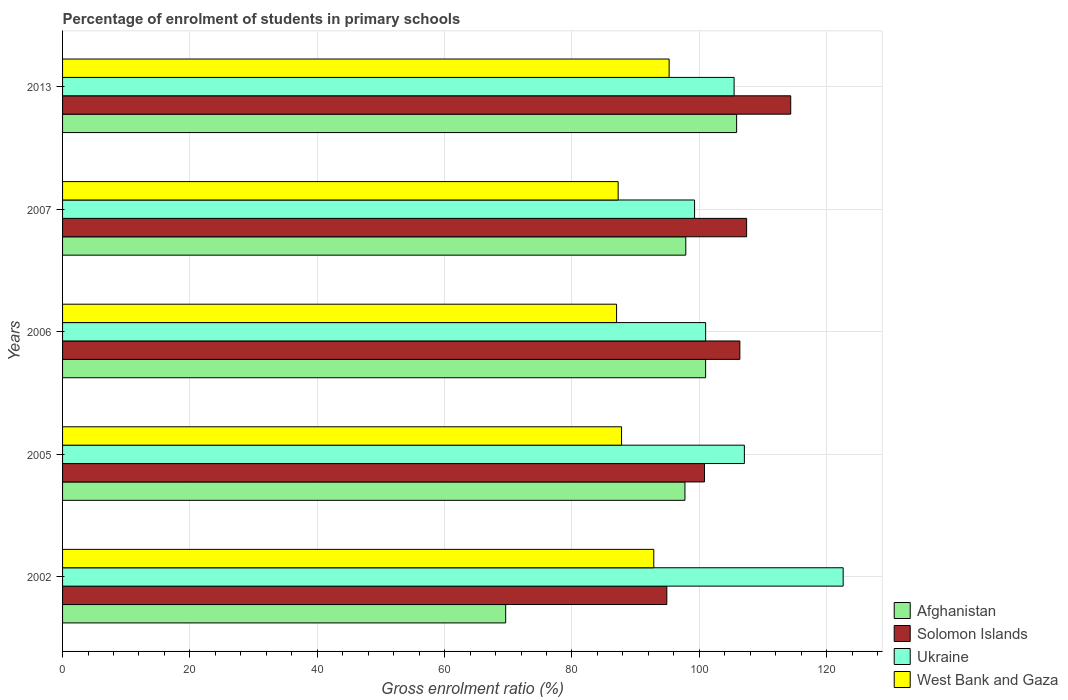How many bars are there on the 4th tick from the bottom?
Make the answer very short. 4. In how many cases, is the number of bars for a given year not equal to the number of legend labels?
Provide a succinct answer. 0. What is the percentage of students enrolled in primary schools in West Bank and Gaza in 2005?
Give a very brief answer. 87.79. Across all years, what is the maximum percentage of students enrolled in primary schools in Solomon Islands?
Make the answer very short. 114.36. Across all years, what is the minimum percentage of students enrolled in primary schools in Solomon Islands?
Offer a terse response. 94.9. In which year was the percentage of students enrolled in primary schools in Ukraine maximum?
Keep it short and to the point. 2002. In which year was the percentage of students enrolled in primary schools in West Bank and Gaza minimum?
Offer a terse response. 2006. What is the total percentage of students enrolled in primary schools in Ukraine in the graph?
Your answer should be very brief. 535.39. What is the difference between the percentage of students enrolled in primary schools in West Bank and Gaza in 2002 and that in 2005?
Offer a terse response. 5.06. What is the difference between the percentage of students enrolled in primary schools in Ukraine in 2006 and the percentage of students enrolled in primary schools in West Bank and Gaza in 2002?
Your answer should be very brief. 8.14. What is the average percentage of students enrolled in primary schools in West Bank and Gaza per year?
Offer a terse response. 90.03. In the year 2005, what is the difference between the percentage of students enrolled in primary schools in Ukraine and percentage of students enrolled in primary schools in Solomon Islands?
Ensure brevity in your answer.  6.27. In how many years, is the percentage of students enrolled in primary schools in Afghanistan greater than 64 %?
Offer a very short reply. 5. What is the ratio of the percentage of students enrolled in primary schools in Ukraine in 2002 to that in 2005?
Your answer should be compact. 1.14. Is the difference between the percentage of students enrolled in primary schools in Ukraine in 2002 and 2006 greater than the difference between the percentage of students enrolled in primary schools in Solomon Islands in 2002 and 2006?
Keep it short and to the point. Yes. What is the difference between the highest and the second highest percentage of students enrolled in primary schools in West Bank and Gaza?
Give a very brief answer. 2.41. What is the difference between the highest and the lowest percentage of students enrolled in primary schools in Solomon Islands?
Give a very brief answer. 19.46. Is it the case that in every year, the sum of the percentage of students enrolled in primary schools in Afghanistan and percentage of students enrolled in primary schools in West Bank and Gaza is greater than the sum of percentage of students enrolled in primary schools in Ukraine and percentage of students enrolled in primary schools in Solomon Islands?
Provide a succinct answer. No. What does the 4th bar from the top in 2007 represents?
Your response must be concise. Afghanistan. What does the 1st bar from the bottom in 2007 represents?
Provide a short and direct response. Afghanistan. Is it the case that in every year, the sum of the percentage of students enrolled in primary schools in Solomon Islands and percentage of students enrolled in primary schools in West Bank and Gaza is greater than the percentage of students enrolled in primary schools in Afghanistan?
Keep it short and to the point. Yes. Are all the bars in the graph horizontal?
Offer a very short reply. Yes. What is the difference between two consecutive major ticks on the X-axis?
Provide a short and direct response. 20. Are the values on the major ticks of X-axis written in scientific E-notation?
Give a very brief answer. No. How are the legend labels stacked?
Give a very brief answer. Vertical. What is the title of the graph?
Keep it short and to the point. Percentage of enrolment of students in primary schools. What is the label or title of the X-axis?
Provide a succinct answer. Gross enrolment ratio (%). What is the Gross enrolment ratio (%) in Afghanistan in 2002?
Your answer should be compact. 69.59. What is the Gross enrolment ratio (%) of Solomon Islands in 2002?
Provide a short and direct response. 94.9. What is the Gross enrolment ratio (%) of Ukraine in 2002?
Ensure brevity in your answer.  122.59. What is the Gross enrolment ratio (%) in West Bank and Gaza in 2002?
Your response must be concise. 92.85. What is the Gross enrolment ratio (%) in Afghanistan in 2005?
Provide a succinct answer. 97.74. What is the Gross enrolment ratio (%) in Solomon Islands in 2005?
Your answer should be very brief. 100.81. What is the Gross enrolment ratio (%) in Ukraine in 2005?
Your response must be concise. 107.08. What is the Gross enrolment ratio (%) in West Bank and Gaza in 2005?
Keep it short and to the point. 87.79. What is the Gross enrolment ratio (%) of Afghanistan in 2006?
Offer a very short reply. 100.99. What is the Gross enrolment ratio (%) of Solomon Islands in 2006?
Ensure brevity in your answer.  106.37. What is the Gross enrolment ratio (%) of Ukraine in 2006?
Your answer should be very brief. 100.99. What is the Gross enrolment ratio (%) in West Bank and Gaza in 2006?
Offer a very short reply. 87.01. What is the Gross enrolment ratio (%) in Afghanistan in 2007?
Give a very brief answer. 97.88. What is the Gross enrolment ratio (%) in Solomon Islands in 2007?
Your answer should be very brief. 107.43. What is the Gross enrolment ratio (%) of Ukraine in 2007?
Offer a very short reply. 99.26. What is the Gross enrolment ratio (%) of West Bank and Gaza in 2007?
Make the answer very short. 87.26. What is the Gross enrolment ratio (%) of Afghanistan in 2013?
Make the answer very short. 105.86. What is the Gross enrolment ratio (%) in Solomon Islands in 2013?
Your response must be concise. 114.36. What is the Gross enrolment ratio (%) in Ukraine in 2013?
Your answer should be very brief. 105.47. What is the Gross enrolment ratio (%) in West Bank and Gaza in 2013?
Provide a short and direct response. 95.26. Across all years, what is the maximum Gross enrolment ratio (%) of Afghanistan?
Give a very brief answer. 105.86. Across all years, what is the maximum Gross enrolment ratio (%) in Solomon Islands?
Your answer should be very brief. 114.36. Across all years, what is the maximum Gross enrolment ratio (%) in Ukraine?
Keep it short and to the point. 122.59. Across all years, what is the maximum Gross enrolment ratio (%) in West Bank and Gaza?
Your response must be concise. 95.26. Across all years, what is the minimum Gross enrolment ratio (%) of Afghanistan?
Keep it short and to the point. 69.59. Across all years, what is the minimum Gross enrolment ratio (%) of Solomon Islands?
Provide a succinct answer. 94.9. Across all years, what is the minimum Gross enrolment ratio (%) in Ukraine?
Ensure brevity in your answer.  99.26. Across all years, what is the minimum Gross enrolment ratio (%) of West Bank and Gaza?
Your answer should be very brief. 87.01. What is the total Gross enrolment ratio (%) in Afghanistan in the graph?
Give a very brief answer. 472.06. What is the total Gross enrolment ratio (%) of Solomon Islands in the graph?
Your response must be concise. 523.87. What is the total Gross enrolment ratio (%) of Ukraine in the graph?
Offer a very short reply. 535.39. What is the total Gross enrolment ratio (%) in West Bank and Gaza in the graph?
Provide a succinct answer. 450.16. What is the difference between the Gross enrolment ratio (%) of Afghanistan in 2002 and that in 2005?
Your answer should be compact. -28.15. What is the difference between the Gross enrolment ratio (%) in Solomon Islands in 2002 and that in 2005?
Offer a terse response. -5.91. What is the difference between the Gross enrolment ratio (%) in Ukraine in 2002 and that in 2005?
Your answer should be very brief. 15.51. What is the difference between the Gross enrolment ratio (%) in West Bank and Gaza in 2002 and that in 2005?
Give a very brief answer. 5.06. What is the difference between the Gross enrolment ratio (%) of Afghanistan in 2002 and that in 2006?
Ensure brevity in your answer.  -31.4. What is the difference between the Gross enrolment ratio (%) of Solomon Islands in 2002 and that in 2006?
Offer a very short reply. -11.47. What is the difference between the Gross enrolment ratio (%) of Ukraine in 2002 and that in 2006?
Your answer should be compact. 21.6. What is the difference between the Gross enrolment ratio (%) in West Bank and Gaza in 2002 and that in 2006?
Keep it short and to the point. 5.84. What is the difference between the Gross enrolment ratio (%) in Afghanistan in 2002 and that in 2007?
Offer a very short reply. -28.29. What is the difference between the Gross enrolment ratio (%) in Solomon Islands in 2002 and that in 2007?
Your response must be concise. -12.53. What is the difference between the Gross enrolment ratio (%) in Ukraine in 2002 and that in 2007?
Offer a very short reply. 23.34. What is the difference between the Gross enrolment ratio (%) in West Bank and Gaza in 2002 and that in 2007?
Ensure brevity in your answer.  5.59. What is the difference between the Gross enrolment ratio (%) in Afghanistan in 2002 and that in 2013?
Provide a short and direct response. -36.27. What is the difference between the Gross enrolment ratio (%) of Solomon Islands in 2002 and that in 2013?
Your answer should be compact. -19.46. What is the difference between the Gross enrolment ratio (%) in Ukraine in 2002 and that in 2013?
Make the answer very short. 17.13. What is the difference between the Gross enrolment ratio (%) in West Bank and Gaza in 2002 and that in 2013?
Your answer should be compact. -2.41. What is the difference between the Gross enrolment ratio (%) in Afghanistan in 2005 and that in 2006?
Your response must be concise. -3.24. What is the difference between the Gross enrolment ratio (%) of Solomon Islands in 2005 and that in 2006?
Keep it short and to the point. -5.56. What is the difference between the Gross enrolment ratio (%) of Ukraine in 2005 and that in 2006?
Your answer should be very brief. 6.08. What is the difference between the Gross enrolment ratio (%) of West Bank and Gaza in 2005 and that in 2006?
Your answer should be compact. 0.78. What is the difference between the Gross enrolment ratio (%) of Afghanistan in 2005 and that in 2007?
Ensure brevity in your answer.  -0.13. What is the difference between the Gross enrolment ratio (%) of Solomon Islands in 2005 and that in 2007?
Provide a succinct answer. -6.62. What is the difference between the Gross enrolment ratio (%) in Ukraine in 2005 and that in 2007?
Your answer should be very brief. 7.82. What is the difference between the Gross enrolment ratio (%) in West Bank and Gaza in 2005 and that in 2007?
Offer a terse response. 0.53. What is the difference between the Gross enrolment ratio (%) in Afghanistan in 2005 and that in 2013?
Make the answer very short. -8.12. What is the difference between the Gross enrolment ratio (%) of Solomon Islands in 2005 and that in 2013?
Give a very brief answer. -13.54. What is the difference between the Gross enrolment ratio (%) in Ukraine in 2005 and that in 2013?
Your answer should be compact. 1.61. What is the difference between the Gross enrolment ratio (%) of West Bank and Gaza in 2005 and that in 2013?
Provide a short and direct response. -7.47. What is the difference between the Gross enrolment ratio (%) of Afghanistan in 2006 and that in 2007?
Ensure brevity in your answer.  3.11. What is the difference between the Gross enrolment ratio (%) in Solomon Islands in 2006 and that in 2007?
Make the answer very short. -1.06. What is the difference between the Gross enrolment ratio (%) in Ukraine in 2006 and that in 2007?
Offer a terse response. 1.74. What is the difference between the Gross enrolment ratio (%) in West Bank and Gaza in 2006 and that in 2007?
Offer a very short reply. -0.25. What is the difference between the Gross enrolment ratio (%) in Afghanistan in 2006 and that in 2013?
Make the answer very short. -4.87. What is the difference between the Gross enrolment ratio (%) of Solomon Islands in 2006 and that in 2013?
Offer a terse response. -7.99. What is the difference between the Gross enrolment ratio (%) of Ukraine in 2006 and that in 2013?
Your answer should be very brief. -4.47. What is the difference between the Gross enrolment ratio (%) of West Bank and Gaza in 2006 and that in 2013?
Make the answer very short. -8.25. What is the difference between the Gross enrolment ratio (%) of Afghanistan in 2007 and that in 2013?
Keep it short and to the point. -7.98. What is the difference between the Gross enrolment ratio (%) of Solomon Islands in 2007 and that in 2013?
Keep it short and to the point. -6.92. What is the difference between the Gross enrolment ratio (%) in Ukraine in 2007 and that in 2013?
Provide a short and direct response. -6.21. What is the difference between the Gross enrolment ratio (%) in West Bank and Gaza in 2007 and that in 2013?
Provide a succinct answer. -8. What is the difference between the Gross enrolment ratio (%) in Afghanistan in 2002 and the Gross enrolment ratio (%) in Solomon Islands in 2005?
Give a very brief answer. -31.22. What is the difference between the Gross enrolment ratio (%) of Afghanistan in 2002 and the Gross enrolment ratio (%) of Ukraine in 2005?
Offer a very short reply. -37.49. What is the difference between the Gross enrolment ratio (%) in Afghanistan in 2002 and the Gross enrolment ratio (%) in West Bank and Gaza in 2005?
Ensure brevity in your answer.  -18.2. What is the difference between the Gross enrolment ratio (%) of Solomon Islands in 2002 and the Gross enrolment ratio (%) of Ukraine in 2005?
Your response must be concise. -12.18. What is the difference between the Gross enrolment ratio (%) of Solomon Islands in 2002 and the Gross enrolment ratio (%) of West Bank and Gaza in 2005?
Make the answer very short. 7.11. What is the difference between the Gross enrolment ratio (%) of Ukraine in 2002 and the Gross enrolment ratio (%) of West Bank and Gaza in 2005?
Ensure brevity in your answer.  34.8. What is the difference between the Gross enrolment ratio (%) of Afghanistan in 2002 and the Gross enrolment ratio (%) of Solomon Islands in 2006?
Your response must be concise. -36.78. What is the difference between the Gross enrolment ratio (%) of Afghanistan in 2002 and the Gross enrolment ratio (%) of Ukraine in 2006?
Offer a very short reply. -31.4. What is the difference between the Gross enrolment ratio (%) of Afghanistan in 2002 and the Gross enrolment ratio (%) of West Bank and Gaza in 2006?
Your answer should be compact. -17.41. What is the difference between the Gross enrolment ratio (%) of Solomon Islands in 2002 and the Gross enrolment ratio (%) of Ukraine in 2006?
Your answer should be compact. -6.09. What is the difference between the Gross enrolment ratio (%) of Solomon Islands in 2002 and the Gross enrolment ratio (%) of West Bank and Gaza in 2006?
Offer a terse response. 7.89. What is the difference between the Gross enrolment ratio (%) of Ukraine in 2002 and the Gross enrolment ratio (%) of West Bank and Gaza in 2006?
Your answer should be very brief. 35.59. What is the difference between the Gross enrolment ratio (%) of Afghanistan in 2002 and the Gross enrolment ratio (%) of Solomon Islands in 2007?
Keep it short and to the point. -37.84. What is the difference between the Gross enrolment ratio (%) in Afghanistan in 2002 and the Gross enrolment ratio (%) in Ukraine in 2007?
Give a very brief answer. -29.66. What is the difference between the Gross enrolment ratio (%) of Afghanistan in 2002 and the Gross enrolment ratio (%) of West Bank and Gaza in 2007?
Your answer should be compact. -17.66. What is the difference between the Gross enrolment ratio (%) of Solomon Islands in 2002 and the Gross enrolment ratio (%) of Ukraine in 2007?
Provide a short and direct response. -4.36. What is the difference between the Gross enrolment ratio (%) in Solomon Islands in 2002 and the Gross enrolment ratio (%) in West Bank and Gaza in 2007?
Keep it short and to the point. 7.64. What is the difference between the Gross enrolment ratio (%) of Ukraine in 2002 and the Gross enrolment ratio (%) of West Bank and Gaza in 2007?
Keep it short and to the point. 35.34. What is the difference between the Gross enrolment ratio (%) in Afghanistan in 2002 and the Gross enrolment ratio (%) in Solomon Islands in 2013?
Ensure brevity in your answer.  -44.76. What is the difference between the Gross enrolment ratio (%) in Afghanistan in 2002 and the Gross enrolment ratio (%) in Ukraine in 2013?
Keep it short and to the point. -35.87. What is the difference between the Gross enrolment ratio (%) of Afghanistan in 2002 and the Gross enrolment ratio (%) of West Bank and Gaza in 2013?
Give a very brief answer. -25.67. What is the difference between the Gross enrolment ratio (%) in Solomon Islands in 2002 and the Gross enrolment ratio (%) in Ukraine in 2013?
Your answer should be compact. -10.57. What is the difference between the Gross enrolment ratio (%) in Solomon Islands in 2002 and the Gross enrolment ratio (%) in West Bank and Gaza in 2013?
Your answer should be very brief. -0.36. What is the difference between the Gross enrolment ratio (%) of Ukraine in 2002 and the Gross enrolment ratio (%) of West Bank and Gaza in 2013?
Ensure brevity in your answer.  27.33. What is the difference between the Gross enrolment ratio (%) in Afghanistan in 2005 and the Gross enrolment ratio (%) in Solomon Islands in 2006?
Your answer should be very brief. -8.62. What is the difference between the Gross enrolment ratio (%) in Afghanistan in 2005 and the Gross enrolment ratio (%) in Ukraine in 2006?
Offer a very short reply. -3.25. What is the difference between the Gross enrolment ratio (%) of Afghanistan in 2005 and the Gross enrolment ratio (%) of West Bank and Gaza in 2006?
Your answer should be very brief. 10.74. What is the difference between the Gross enrolment ratio (%) of Solomon Islands in 2005 and the Gross enrolment ratio (%) of Ukraine in 2006?
Offer a very short reply. -0.18. What is the difference between the Gross enrolment ratio (%) in Solomon Islands in 2005 and the Gross enrolment ratio (%) in West Bank and Gaza in 2006?
Your response must be concise. 13.81. What is the difference between the Gross enrolment ratio (%) of Ukraine in 2005 and the Gross enrolment ratio (%) of West Bank and Gaza in 2006?
Ensure brevity in your answer.  20.07. What is the difference between the Gross enrolment ratio (%) of Afghanistan in 2005 and the Gross enrolment ratio (%) of Solomon Islands in 2007?
Provide a succinct answer. -9.69. What is the difference between the Gross enrolment ratio (%) in Afghanistan in 2005 and the Gross enrolment ratio (%) in Ukraine in 2007?
Provide a short and direct response. -1.51. What is the difference between the Gross enrolment ratio (%) of Afghanistan in 2005 and the Gross enrolment ratio (%) of West Bank and Gaza in 2007?
Offer a very short reply. 10.49. What is the difference between the Gross enrolment ratio (%) in Solomon Islands in 2005 and the Gross enrolment ratio (%) in Ukraine in 2007?
Provide a succinct answer. 1.56. What is the difference between the Gross enrolment ratio (%) in Solomon Islands in 2005 and the Gross enrolment ratio (%) in West Bank and Gaza in 2007?
Provide a succinct answer. 13.56. What is the difference between the Gross enrolment ratio (%) in Ukraine in 2005 and the Gross enrolment ratio (%) in West Bank and Gaza in 2007?
Your answer should be compact. 19.82. What is the difference between the Gross enrolment ratio (%) in Afghanistan in 2005 and the Gross enrolment ratio (%) in Solomon Islands in 2013?
Keep it short and to the point. -16.61. What is the difference between the Gross enrolment ratio (%) in Afghanistan in 2005 and the Gross enrolment ratio (%) in Ukraine in 2013?
Provide a short and direct response. -7.72. What is the difference between the Gross enrolment ratio (%) of Afghanistan in 2005 and the Gross enrolment ratio (%) of West Bank and Gaza in 2013?
Offer a very short reply. 2.49. What is the difference between the Gross enrolment ratio (%) in Solomon Islands in 2005 and the Gross enrolment ratio (%) in Ukraine in 2013?
Your answer should be compact. -4.65. What is the difference between the Gross enrolment ratio (%) of Solomon Islands in 2005 and the Gross enrolment ratio (%) of West Bank and Gaza in 2013?
Your answer should be compact. 5.55. What is the difference between the Gross enrolment ratio (%) in Ukraine in 2005 and the Gross enrolment ratio (%) in West Bank and Gaza in 2013?
Your answer should be compact. 11.82. What is the difference between the Gross enrolment ratio (%) in Afghanistan in 2006 and the Gross enrolment ratio (%) in Solomon Islands in 2007?
Give a very brief answer. -6.44. What is the difference between the Gross enrolment ratio (%) in Afghanistan in 2006 and the Gross enrolment ratio (%) in Ukraine in 2007?
Your response must be concise. 1.73. What is the difference between the Gross enrolment ratio (%) in Afghanistan in 2006 and the Gross enrolment ratio (%) in West Bank and Gaza in 2007?
Your answer should be compact. 13.73. What is the difference between the Gross enrolment ratio (%) in Solomon Islands in 2006 and the Gross enrolment ratio (%) in Ukraine in 2007?
Give a very brief answer. 7.11. What is the difference between the Gross enrolment ratio (%) of Solomon Islands in 2006 and the Gross enrolment ratio (%) of West Bank and Gaza in 2007?
Your response must be concise. 19.11. What is the difference between the Gross enrolment ratio (%) in Ukraine in 2006 and the Gross enrolment ratio (%) in West Bank and Gaza in 2007?
Keep it short and to the point. 13.74. What is the difference between the Gross enrolment ratio (%) in Afghanistan in 2006 and the Gross enrolment ratio (%) in Solomon Islands in 2013?
Provide a short and direct response. -13.37. What is the difference between the Gross enrolment ratio (%) in Afghanistan in 2006 and the Gross enrolment ratio (%) in Ukraine in 2013?
Provide a succinct answer. -4.48. What is the difference between the Gross enrolment ratio (%) of Afghanistan in 2006 and the Gross enrolment ratio (%) of West Bank and Gaza in 2013?
Offer a very short reply. 5.73. What is the difference between the Gross enrolment ratio (%) of Solomon Islands in 2006 and the Gross enrolment ratio (%) of Ukraine in 2013?
Your response must be concise. 0.9. What is the difference between the Gross enrolment ratio (%) of Solomon Islands in 2006 and the Gross enrolment ratio (%) of West Bank and Gaza in 2013?
Provide a short and direct response. 11.11. What is the difference between the Gross enrolment ratio (%) in Ukraine in 2006 and the Gross enrolment ratio (%) in West Bank and Gaza in 2013?
Keep it short and to the point. 5.74. What is the difference between the Gross enrolment ratio (%) in Afghanistan in 2007 and the Gross enrolment ratio (%) in Solomon Islands in 2013?
Offer a terse response. -16.48. What is the difference between the Gross enrolment ratio (%) of Afghanistan in 2007 and the Gross enrolment ratio (%) of Ukraine in 2013?
Keep it short and to the point. -7.59. What is the difference between the Gross enrolment ratio (%) in Afghanistan in 2007 and the Gross enrolment ratio (%) in West Bank and Gaza in 2013?
Provide a succinct answer. 2.62. What is the difference between the Gross enrolment ratio (%) of Solomon Islands in 2007 and the Gross enrolment ratio (%) of Ukraine in 2013?
Offer a terse response. 1.97. What is the difference between the Gross enrolment ratio (%) of Solomon Islands in 2007 and the Gross enrolment ratio (%) of West Bank and Gaza in 2013?
Give a very brief answer. 12.17. What is the difference between the Gross enrolment ratio (%) in Ukraine in 2007 and the Gross enrolment ratio (%) in West Bank and Gaza in 2013?
Give a very brief answer. 4. What is the average Gross enrolment ratio (%) of Afghanistan per year?
Your answer should be compact. 94.41. What is the average Gross enrolment ratio (%) in Solomon Islands per year?
Ensure brevity in your answer.  104.77. What is the average Gross enrolment ratio (%) in Ukraine per year?
Your answer should be very brief. 107.08. What is the average Gross enrolment ratio (%) in West Bank and Gaza per year?
Ensure brevity in your answer.  90.03. In the year 2002, what is the difference between the Gross enrolment ratio (%) in Afghanistan and Gross enrolment ratio (%) in Solomon Islands?
Offer a terse response. -25.31. In the year 2002, what is the difference between the Gross enrolment ratio (%) in Afghanistan and Gross enrolment ratio (%) in Ukraine?
Your answer should be very brief. -53. In the year 2002, what is the difference between the Gross enrolment ratio (%) of Afghanistan and Gross enrolment ratio (%) of West Bank and Gaza?
Offer a terse response. -23.26. In the year 2002, what is the difference between the Gross enrolment ratio (%) in Solomon Islands and Gross enrolment ratio (%) in Ukraine?
Your response must be concise. -27.69. In the year 2002, what is the difference between the Gross enrolment ratio (%) in Solomon Islands and Gross enrolment ratio (%) in West Bank and Gaza?
Offer a terse response. 2.05. In the year 2002, what is the difference between the Gross enrolment ratio (%) in Ukraine and Gross enrolment ratio (%) in West Bank and Gaza?
Make the answer very short. 29.74. In the year 2005, what is the difference between the Gross enrolment ratio (%) in Afghanistan and Gross enrolment ratio (%) in Solomon Islands?
Provide a short and direct response. -3.07. In the year 2005, what is the difference between the Gross enrolment ratio (%) in Afghanistan and Gross enrolment ratio (%) in Ukraine?
Provide a succinct answer. -9.33. In the year 2005, what is the difference between the Gross enrolment ratio (%) of Afghanistan and Gross enrolment ratio (%) of West Bank and Gaza?
Your answer should be compact. 9.95. In the year 2005, what is the difference between the Gross enrolment ratio (%) in Solomon Islands and Gross enrolment ratio (%) in Ukraine?
Keep it short and to the point. -6.27. In the year 2005, what is the difference between the Gross enrolment ratio (%) in Solomon Islands and Gross enrolment ratio (%) in West Bank and Gaza?
Offer a very short reply. 13.02. In the year 2005, what is the difference between the Gross enrolment ratio (%) in Ukraine and Gross enrolment ratio (%) in West Bank and Gaza?
Ensure brevity in your answer.  19.29. In the year 2006, what is the difference between the Gross enrolment ratio (%) of Afghanistan and Gross enrolment ratio (%) of Solomon Islands?
Provide a succinct answer. -5.38. In the year 2006, what is the difference between the Gross enrolment ratio (%) of Afghanistan and Gross enrolment ratio (%) of Ukraine?
Give a very brief answer. -0.01. In the year 2006, what is the difference between the Gross enrolment ratio (%) of Afghanistan and Gross enrolment ratio (%) of West Bank and Gaza?
Offer a terse response. 13.98. In the year 2006, what is the difference between the Gross enrolment ratio (%) in Solomon Islands and Gross enrolment ratio (%) in Ukraine?
Ensure brevity in your answer.  5.37. In the year 2006, what is the difference between the Gross enrolment ratio (%) in Solomon Islands and Gross enrolment ratio (%) in West Bank and Gaza?
Offer a terse response. 19.36. In the year 2006, what is the difference between the Gross enrolment ratio (%) of Ukraine and Gross enrolment ratio (%) of West Bank and Gaza?
Your answer should be compact. 13.99. In the year 2007, what is the difference between the Gross enrolment ratio (%) in Afghanistan and Gross enrolment ratio (%) in Solomon Islands?
Provide a short and direct response. -9.55. In the year 2007, what is the difference between the Gross enrolment ratio (%) in Afghanistan and Gross enrolment ratio (%) in Ukraine?
Keep it short and to the point. -1.38. In the year 2007, what is the difference between the Gross enrolment ratio (%) of Afghanistan and Gross enrolment ratio (%) of West Bank and Gaza?
Ensure brevity in your answer.  10.62. In the year 2007, what is the difference between the Gross enrolment ratio (%) in Solomon Islands and Gross enrolment ratio (%) in Ukraine?
Your answer should be very brief. 8.18. In the year 2007, what is the difference between the Gross enrolment ratio (%) of Solomon Islands and Gross enrolment ratio (%) of West Bank and Gaza?
Give a very brief answer. 20.17. In the year 2007, what is the difference between the Gross enrolment ratio (%) in Ukraine and Gross enrolment ratio (%) in West Bank and Gaza?
Keep it short and to the point. 12. In the year 2013, what is the difference between the Gross enrolment ratio (%) of Afghanistan and Gross enrolment ratio (%) of Solomon Islands?
Your answer should be very brief. -8.5. In the year 2013, what is the difference between the Gross enrolment ratio (%) in Afghanistan and Gross enrolment ratio (%) in Ukraine?
Ensure brevity in your answer.  0.39. In the year 2013, what is the difference between the Gross enrolment ratio (%) in Afghanistan and Gross enrolment ratio (%) in West Bank and Gaza?
Your response must be concise. 10.6. In the year 2013, what is the difference between the Gross enrolment ratio (%) of Solomon Islands and Gross enrolment ratio (%) of Ukraine?
Your response must be concise. 8.89. In the year 2013, what is the difference between the Gross enrolment ratio (%) in Solomon Islands and Gross enrolment ratio (%) in West Bank and Gaza?
Make the answer very short. 19.1. In the year 2013, what is the difference between the Gross enrolment ratio (%) of Ukraine and Gross enrolment ratio (%) of West Bank and Gaza?
Provide a succinct answer. 10.21. What is the ratio of the Gross enrolment ratio (%) in Afghanistan in 2002 to that in 2005?
Provide a succinct answer. 0.71. What is the ratio of the Gross enrolment ratio (%) in Solomon Islands in 2002 to that in 2005?
Offer a terse response. 0.94. What is the ratio of the Gross enrolment ratio (%) of Ukraine in 2002 to that in 2005?
Provide a succinct answer. 1.14. What is the ratio of the Gross enrolment ratio (%) in West Bank and Gaza in 2002 to that in 2005?
Ensure brevity in your answer.  1.06. What is the ratio of the Gross enrolment ratio (%) in Afghanistan in 2002 to that in 2006?
Ensure brevity in your answer.  0.69. What is the ratio of the Gross enrolment ratio (%) of Solomon Islands in 2002 to that in 2006?
Ensure brevity in your answer.  0.89. What is the ratio of the Gross enrolment ratio (%) in Ukraine in 2002 to that in 2006?
Provide a succinct answer. 1.21. What is the ratio of the Gross enrolment ratio (%) in West Bank and Gaza in 2002 to that in 2006?
Your answer should be very brief. 1.07. What is the ratio of the Gross enrolment ratio (%) of Afghanistan in 2002 to that in 2007?
Offer a terse response. 0.71. What is the ratio of the Gross enrolment ratio (%) of Solomon Islands in 2002 to that in 2007?
Ensure brevity in your answer.  0.88. What is the ratio of the Gross enrolment ratio (%) in Ukraine in 2002 to that in 2007?
Ensure brevity in your answer.  1.24. What is the ratio of the Gross enrolment ratio (%) of West Bank and Gaza in 2002 to that in 2007?
Offer a terse response. 1.06. What is the ratio of the Gross enrolment ratio (%) of Afghanistan in 2002 to that in 2013?
Give a very brief answer. 0.66. What is the ratio of the Gross enrolment ratio (%) in Solomon Islands in 2002 to that in 2013?
Your answer should be very brief. 0.83. What is the ratio of the Gross enrolment ratio (%) in Ukraine in 2002 to that in 2013?
Give a very brief answer. 1.16. What is the ratio of the Gross enrolment ratio (%) in West Bank and Gaza in 2002 to that in 2013?
Offer a very short reply. 0.97. What is the ratio of the Gross enrolment ratio (%) of Afghanistan in 2005 to that in 2006?
Your response must be concise. 0.97. What is the ratio of the Gross enrolment ratio (%) in Solomon Islands in 2005 to that in 2006?
Offer a terse response. 0.95. What is the ratio of the Gross enrolment ratio (%) in Ukraine in 2005 to that in 2006?
Give a very brief answer. 1.06. What is the ratio of the Gross enrolment ratio (%) of Solomon Islands in 2005 to that in 2007?
Your answer should be very brief. 0.94. What is the ratio of the Gross enrolment ratio (%) in Ukraine in 2005 to that in 2007?
Ensure brevity in your answer.  1.08. What is the ratio of the Gross enrolment ratio (%) of Afghanistan in 2005 to that in 2013?
Offer a terse response. 0.92. What is the ratio of the Gross enrolment ratio (%) of Solomon Islands in 2005 to that in 2013?
Keep it short and to the point. 0.88. What is the ratio of the Gross enrolment ratio (%) in Ukraine in 2005 to that in 2013?
Keep it short and to the point. 1.02. What is the ratio of the Gross enrolment ratio (%) in West Bank and Gaza in 2005 to that in 2013?
Keep it short and to the point. 0.92. What is the ratio of the Gross enrolment ratio (%) in Afghanistan in 2006 to that in 2007?
Offer a very short reply. 1.03. What is the ratio of the Gross enrolment ratio (%) of Solomon Islands in 2006 to that in 2007?
Make the answer very short. 0.99. What is the ratio of the Gross enrolment ratio (%) of Ukraine in 2006 to that in 2007?
Keep it short and to the point. 1.02. What is the ratio of the Gross enrolment ratio (%) of Afghanistan in 2006 to that in 2013?
Give a very brief answer. 0.95. What is the ratio of the Gross enrolment ratio (%) of Solomon Islands in 2006 to that in 2013?
Your response must be concise. 0.93. What is the ratio of the Gross enrolment ratio (%) in Ukraine in 2006 to that in 2013?
Offer a terse response. 0.96. What is the ratio of the Gross enrolment ratio (%) in West Bank and Gaza in 2006 to that in 2013?
Offer a very short reply. 0.91. What is the ratio of the Gross enrolment ratio (%) in Afghanistan in 2007 to that in 2013?
Offer a terse response. 0.92. What is the ratio of the Gross enrolment ratio (%) of Solomon Islands in 2007 to that in 2013?
Provide a succinct answer. 0.94. What is the ratio of the Gross enrolment ratio (%) in Ukraine in 2007 to that in 2013?
Make the answer very short. 0.94. What is the ratio of the Gross enrolment ratio (%) in West Bank and Gaza in 2007 to that in 2013?
Keep it short and to the point. 0.92. What is the difference between the highest and the second highest Gross enrolment ratio (%) of Afghanistan?
Offer a very short reply. 4.87. What is the difference between the highest and the second highest Gross enrolment ratio (%) of Solomon Islands?
Give a very brief answer. 6.92. What is the difference between the highest and the second highest Gross enrolment ratio (%) of Ukraine?
Make the answer very short. 15.51. What is the difference between the highest and the second highest Gross enrolment ratio (%) of West Bank and Gaza?
Offer a very short reply. 2.41. What is the difference between the highest and the lowest Gross enrolment ratio (%) in Afghanistan?
Ensure brevity in your answer.  36.27. What is the difference between the highest and the lowest Gross enrolment ratio (%) of Solomon Islands?
Your response must be concise. 19.46. What is the difference between the highest and the lowest Gross enrolment ratio (%) of Ukraine?
Offer a very short reply. 23.34. What is the difference between the highest and the lowest Gross enrolment ratio (%) in West Bank and Gaza?
Offer a terse response. 8.25. 